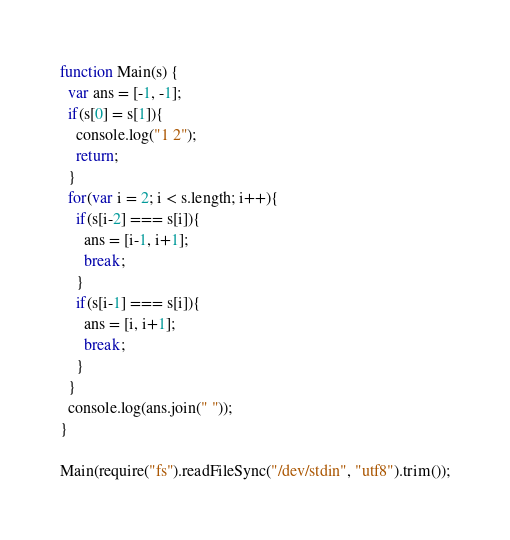<code> <loc_0><loc_0><loc_500><loc_500><_JavaScript_>function Main(s) {
  var ans = [-1, -1];
  if(s[0] = s[1]){
    console.log("1 2");
    return;
  }
  for(var i = 2; i < s.length; i++){
    if(s[i-2] === s[i]){
      ans = [i-1, i+1];
      break;
    }
    if(s[i-1] === s[i]){
      ans = [i, i+1];
      break;
    }
  }
  console.log(ans.join(" "));
}

Main(require("fs").readFileSync("/dev/stdin", "utf8").trim());</code> 